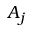<formula> <loc_0><loc_0><loc_500><loc_500>A _ { j }</formula> 